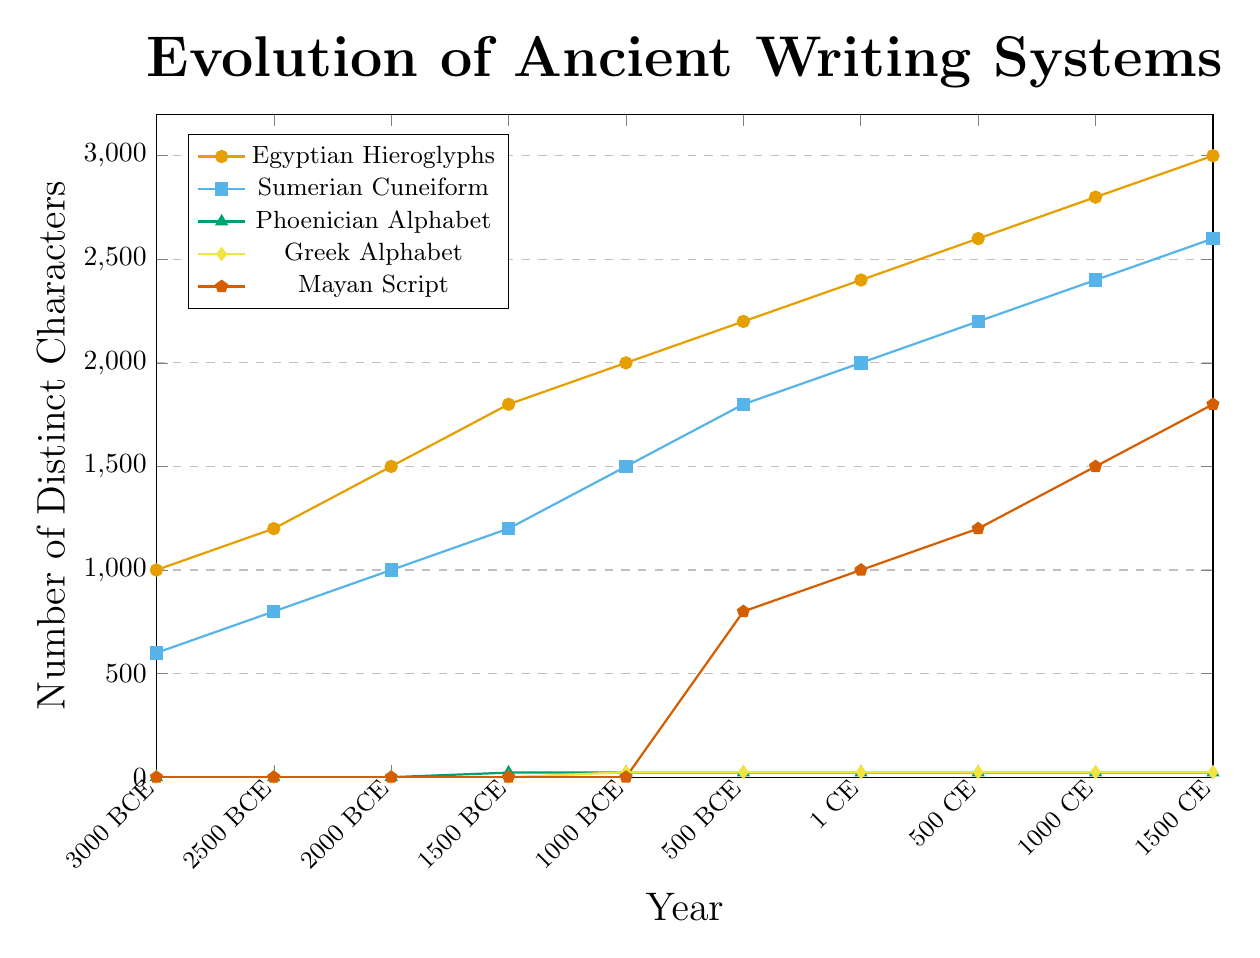What is the number of distinct characters in Egyptian Hieroglyphs around 1 CE? According to the figure, the number of distinct characters in Egyptian Hieroglyphs around 1 CE can be found by looking at the plot for Egyptian Hieroglyphs at the year 1 CE. This value is 2400.
Answer: 2400 Which writing system had the highest number of distinct characters in 1500 CE? To determine which writing system had the highest number of distinct characters in 1500 CE, look at the plot values for all writing systems at that year. The Egyptian Hieroglyphs had the highest value of 3000 distinct characters.
Answer: Egyptian Hieroglyphs How many more distinct characters did Sumerian Cuneiform have than Greek Alphabet in 500 BCE? To find the difference in the number of distinct characters between Sumerian Cuneiform and Greek Alphabet in 500 BCE, look at their respective values. Sumerian Cuneiform had 1800 characters and Greek Alphabet had 24 characters. The difference is 1800 - 24 = 1776.
Answer: 1776 What's the increase in the number of distinct characters for Mayan Script from 500 CE to 1000 CE? The number of distinct characters for Mayan Script in 500 CE is 1200 and in 1000 CE is 1500. The increase is calculated by subtracting the earlier value from the later value: 1500 - 1200 = 300.
Answer: 300 Which writing systems had a constant number of distinct characters over time? To find which writing systems had a constant number of distinct characters over time, observe the plot lines. The Phoenician Alphabet had a constant number of 22 characters, and the Greek Alphabet had a constant number of 24 characters.
Answer: Phoenician Alphabet, Greek Alphabet Compare the growth in the number of distinct characters of Egyptian Hieroglyphs and Sumerian Cuneiform between 1000 BCE and 500 CE. Which one grew more? The Egyptian Hieroglyphs grew from 2000 characters in 1000 BCE to 2600 characters in 500 CE, an increase of 2600 - 2000 = 600 characters. The Sumerian Cuneiform grew from 1500 characters in 1000 BCE to 2200 characters in 500 CE, an increase of 2200 - 1500 = 700 characters. Therefore, Sumerian Cuneiform grew more.
Answer: Sumerian Cuneiform In which year did both Egyptian Hieroglyphs and Sumerian Cuneiform first reach 2000 distinct characters? To find the year when both Egyptian Hieroglyphs and Sumerian Cuneiform first reached 2000 distinct characters, observe their respective plot lines. Egyptian Hieroglyphs reached 2000 characters around 1000 BCE, while Sumerian Cuneiform reached 2000 characters around 1 CE.
Answer: 1 CE 